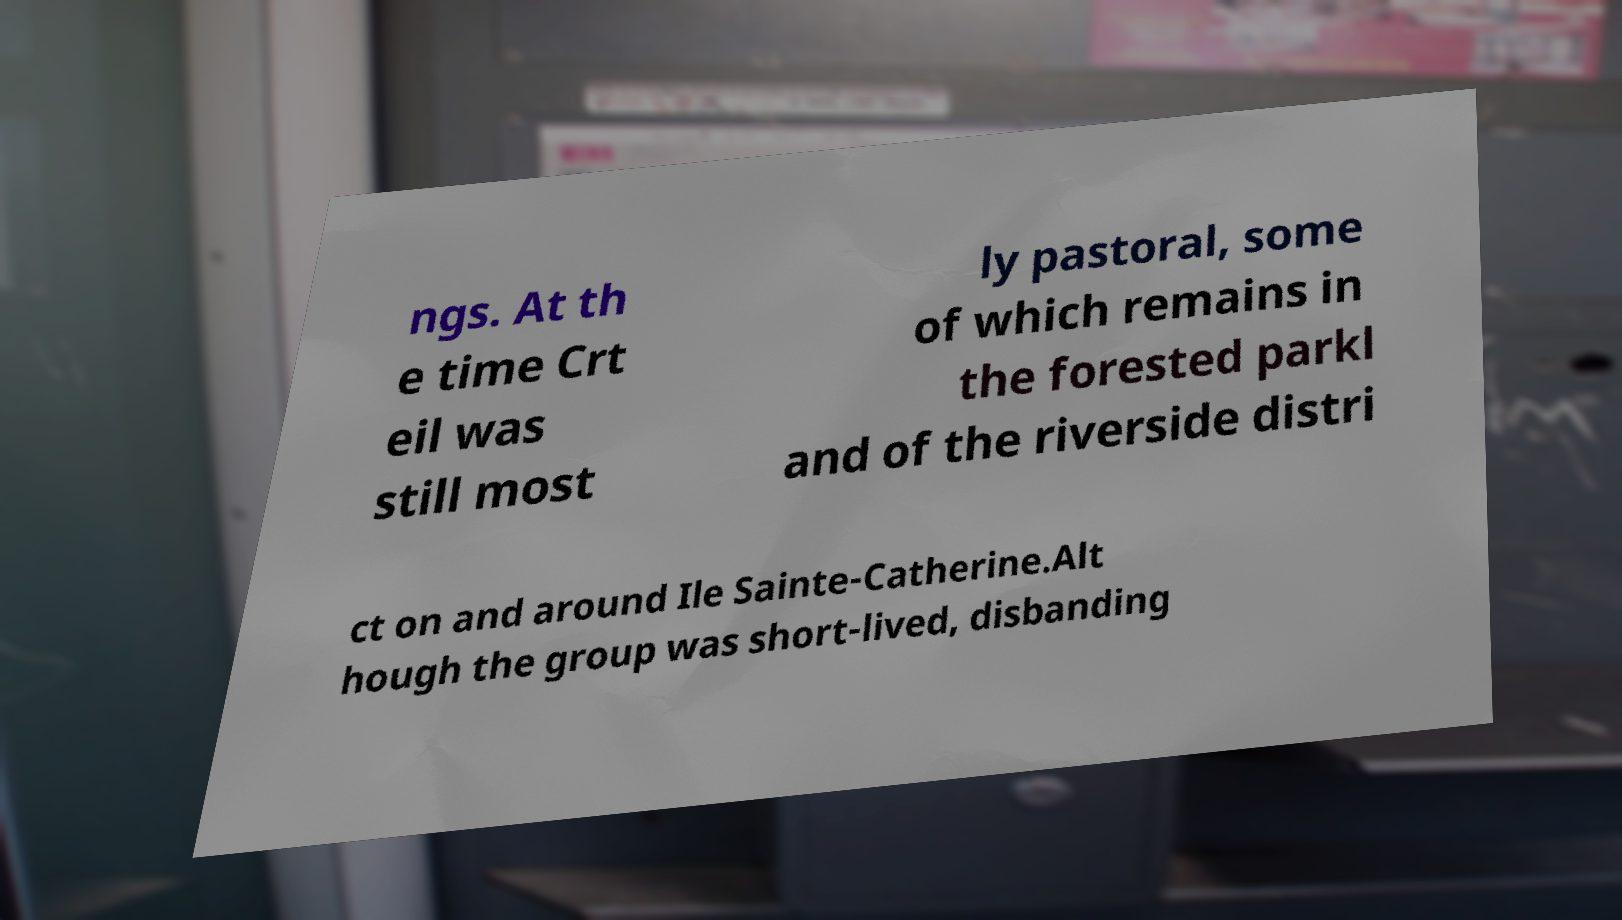There's text embedded in this image that I need extracted. Can you transcribe it verbatim? ngs. At th e time Crt eil was still most ly pastoral, some of which remains in the forested parkl and of the riverside distri ct on and around Ile Sainte-Catherine.Alt hough the group was short-lived, disbanding 